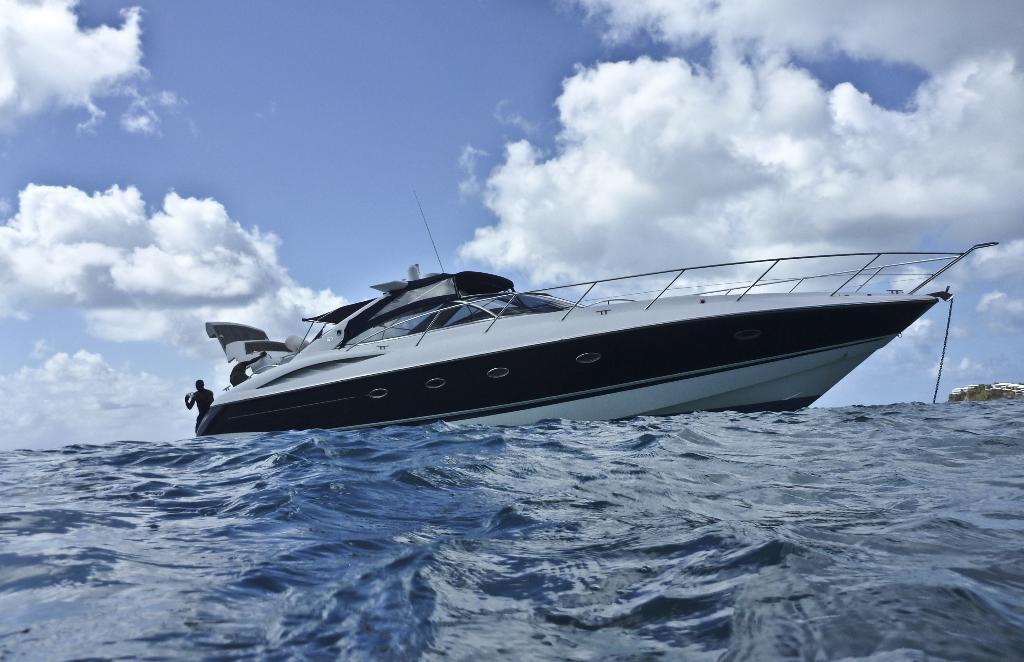How would you summarize this image in a sentence or two? In the background we can see clouds in the sky. In this picture we can see a boat. On the left side of the picture a person is visible. At the bottom portion of the picture we can see the water. 